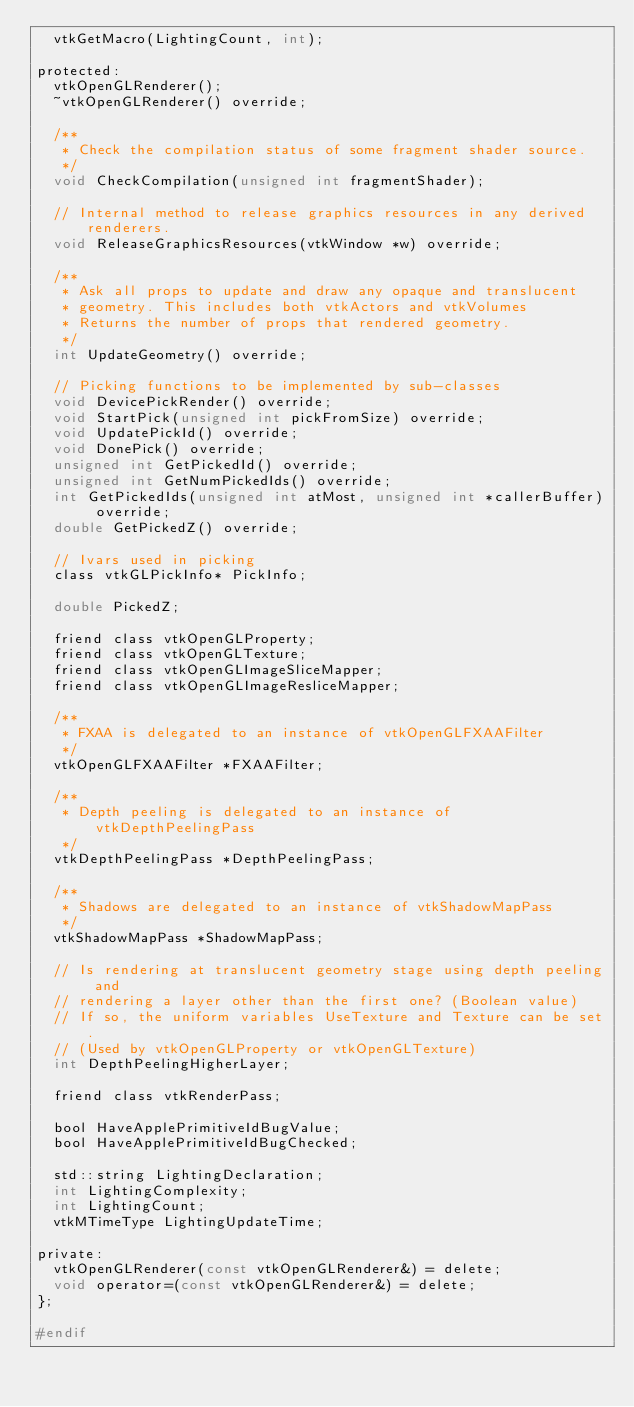<code> <loc_0><loc_0><loc_500><loc_500><_C_>  vtkGetMacro(LightingCount, int);

protected:
  vtkOpenGLRenderer();
  ~vtkOpenGLRenderer() override;

  /**
   * Check the compilation status of some fragment shader source.
   */
  void CheckCompilation(unsigned int fragmentShader);

  // Internal method to release graphics resources in any derived renderers.
  void ReleaseGraphicsResources(vtkWindow *w) override;

  /**
   * Ask all props to update and draw any opaque and translucent
   * geometry. This includes both vtkActors and vtkVolumes
   * Returns the number of props that rendered geometry.
   */
  int UpdateGeometry() override;

  // Picking functions to be implemented by sub-classes
  void DevicePickRender() override;
  void StartPick(unsigned int pickFromSize) override;
  void UpdatePickId() override;
  void DonePick() override;
  unsigned int GetPickedId() override;
  unsigned int GetNumPickedIds() override;
  int GetPickedIds(unsigned int atMost, unsigned int *callerBuffer) override;
  double GetPickedZ() override;

  // Ivars used in picking
  class vtkGLPickInfo* PickInfo;

  double PickedZ;

  friend class vtkOpenGLProperty;
  friend class vtkOpenGLTexture;
  friend class vtkOpenGLImageSliceMapper;
  friend class vtkOpenGLImageResliceMapper;

  /**
   * FXAA is delegated to an instance of vtkOpenGLFXAAFilter
   */
  vtkOpenGLFXAAFilter *FXAAFilter;

  /**
   * Depth peeling is delegated to an instance of vtkDepthPeelingPass
   */
  vtkDepthPeelingPass *DepthPeelingPass;

  /**
   * Shadows are delegated to an instance of vtkShadowMapPass
   */
  vtkShadowMapPass *ShadowMapPass;

  // Is rendering at translucent geometry stage using depth peeling and
  // rendering a layer other than the first one? (Boolean value)
  // If so, the uniform variables UseTexture and Texture can be set.
  // (Used by vtkOpenGLProperty or vtkOpenGLTexture)
  int DepthPeelingHigherLayer;

  friend class vtkRenderPass;

  bool HaveApplePrimitiveIdBugValue;
  bool HaveApplePrimitiveIdBugChecked;

  std::string LightingDeclaration;
  int LightingComplexity;
  int LightingCount;
  vtkMTimeType LightingUpdateTime;

private:
  vtkOpenGLRenderer(const vtkOpenGLRenderer&) = delete;
  void operator=(const vtkOpenGLRenderer&) = delete;
};

#endif
</code> 